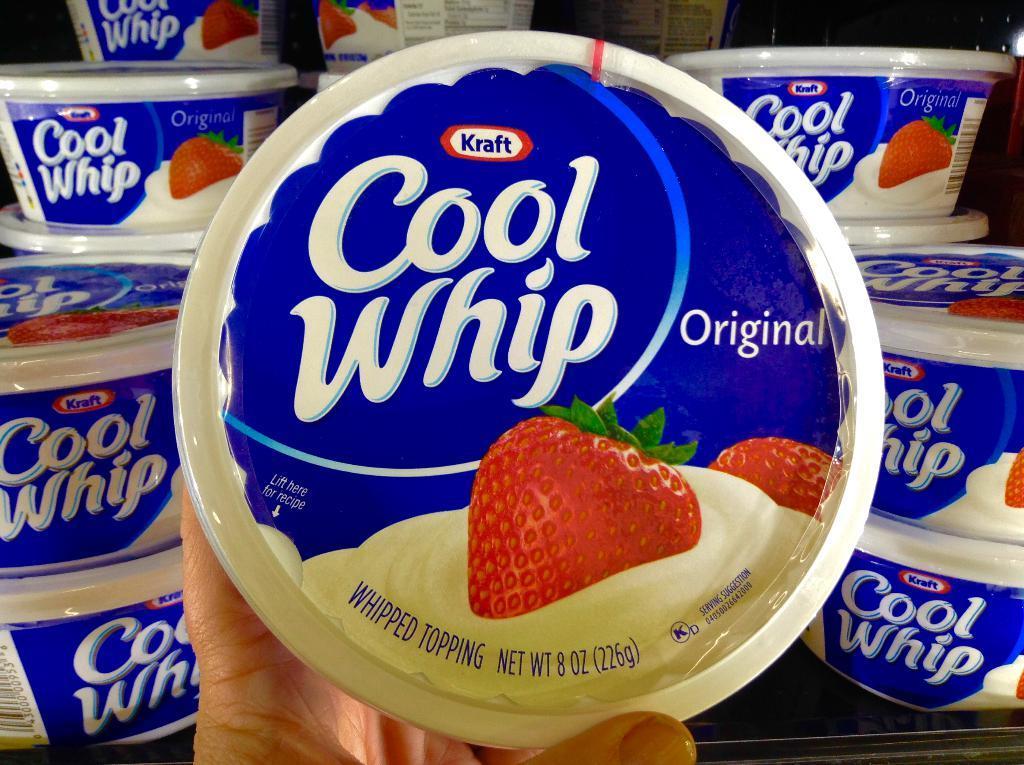How would you summarize this image in a sentence or two? There is a person holding a cup. In the background, there are cups arranged on the table. And the background is dark in color. 